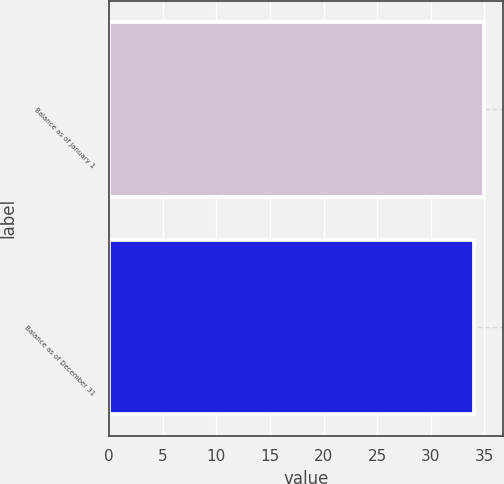Convert chart. <chart><loc_0><loc_0><loc_500><loc_500><bar_chart><fcel>Balance as of January 1<fcel>Balance as of December 31<nl><fcel>35<fcel>34<nl></chart> 